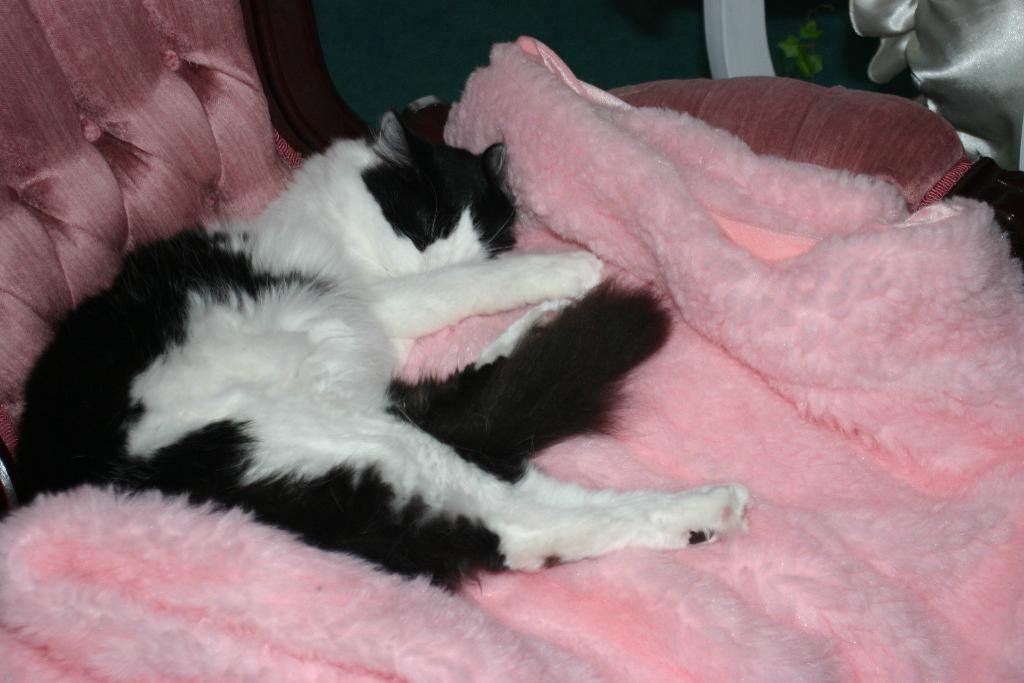Can you describe this image briefly? In the image in the center, we can see one bed. On the bed, we can see one animal lying, which is in black and white color. In the background there is a wall and few others objects. 